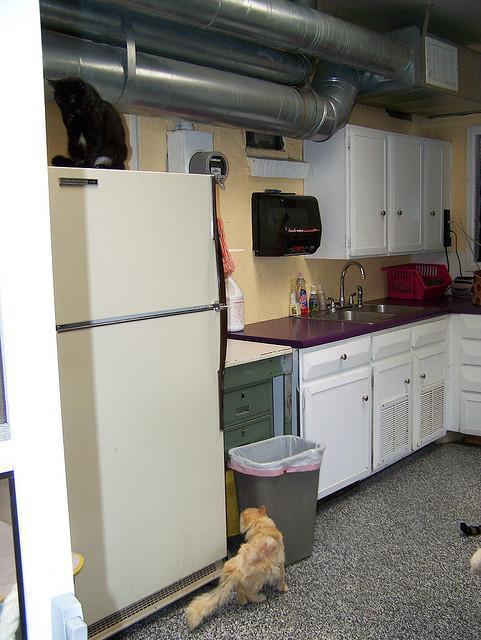How many cats do you see?
Give a very brief answer. 2. How many cats can be seen?
Give a very brief answer. 2. 